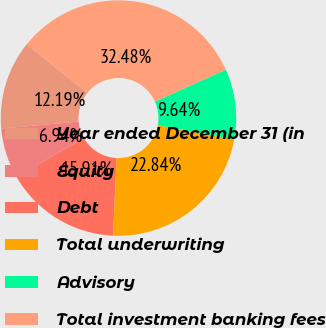<chart> <loc_0><loc_0><loc_500><loc_500><pie_chart><fcel>Year ended December 31 (in<fcel>Equity<fcel>Debt<fcel>Total underwriting<fcel>Advisory<fcel>Total investment banking fees<nl><fcel>12.19%<fcel>6.94%<fcel>15.91%<fcel>22.84%<fcel>9.64%<fcel>32.48%<nl></chart> 